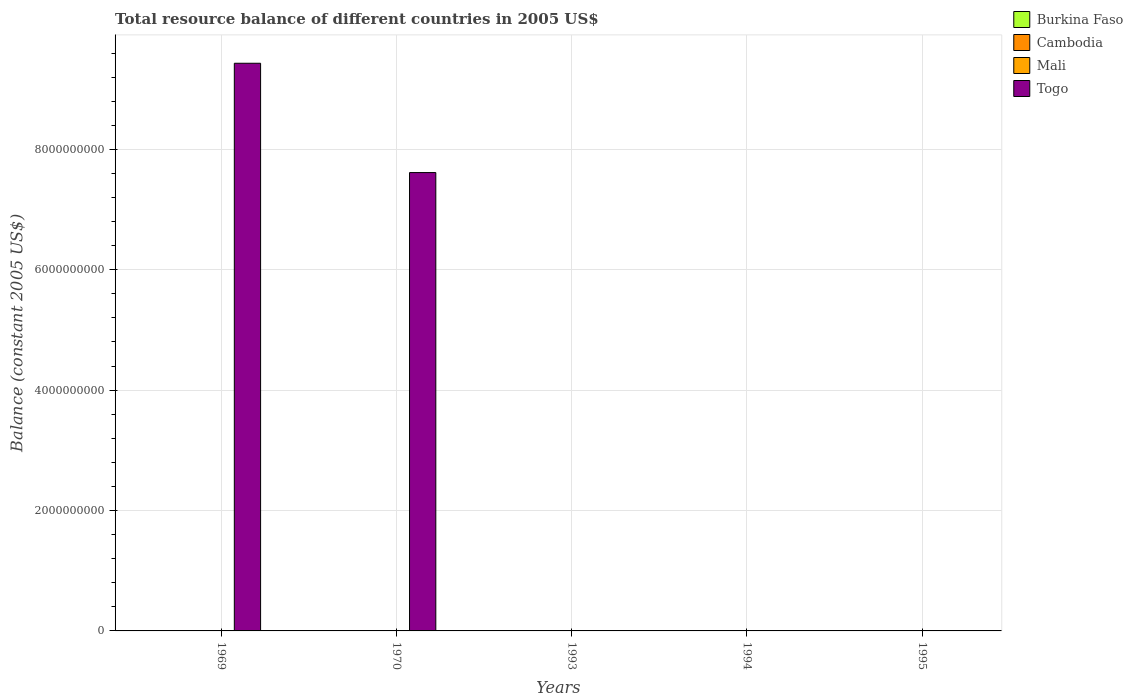How many different coloured bars are there?
Offer a very short reply. 1. Are the number of bars per tick equal to the number of legend labels?
Your answer should be compact. No. Are the number of bars on each tick of the X-axis equal?
Keep it short and to the point. No. How many bars are there on the 4th tick from the left?
Your answer should be compact. 0. How many bars are there on the 4th tick from the right?
Give a very brief answer. 1. What is the total resource balance in Togo in 1970?
Offer a very short reply. 7.61e+09. Across all years, what is the minimum total resource balance in Togo?
Provide a short and direct response. 0. In which year was the total resource balance in Togo maximum?
Your answer should be very brief. 1969. What is the difference between the total resource balance in Cambodia in 1994 and the total resource balance in Burkina Faso in 1995?
Your answer should be compact. 0. What is the difference between the highest and the lowest total resource balance in Togo?
Offer a very short reply. 9.43e+09. In how many years, is the total resource balance in Burkina Faso greater than the average total resource balance in Burkina Faso taken over all years?
Ensure brevity in your answer.  0. Is it the case that in every year, the sum of the total resource balance in Mali and total resource balance in Burkina Faso is greater than the sum of total resource balance in Togo and total resource balance in Cambodia?
Make the answer very short. No. Is it the case that in every year, the sum of the total resource balance in Burkina Faso and total resource balance in Mali is greater than the total resource balance in Cambodia?
Provide a short and direct response. No. Are all the bars in the graph horizontal?
Provide a short and direct response. No. Does the graph contain grids?
Offer a very short reply. Yes. Where does the legend appear in the graph?
Provide a succinct answer. Top right. How many legend labels are there?
Offer a very short reply. 4. How are the legend labels stacked?
Your response must be concise. Vertical. What is the title of the graph?
Your answer should be compact. Total resource balance of different countries in 2005 US$. What is the label or title of the Y-axis?
Provide a succinct answer. Balance (constant 2005 US$). What is the Balance (constant 2005 US$) in Cambodia in 1969?
Provide a succinct answer. 0. What is the Balance (constant 2005 US$) in Mali in 1969?
Ensure brevity in your answer.  0. What is the Balance (constant 2005 US$) of Togo in 1969?
Keep it short and to the point. 9.43e+09. What is the Balance (constant 2005 US$) in Mali in 1970?
Provide a short and direct response. 0. What is the Balance (constant 2005 US$) of Togo in 1970?
Offer a very short reply. 7.61e+09. What is the Balance (constant 2005 US$) in Cambodia in 1993?
Your answer should be compact. 0. What is the Balance (constant 2005 US$) of Burkina Faso in 1994?
Provide a succinct answer. 0. What is the Balance (constant 2005 US$) in Cambodia in 1995?
Your answer should be very brief. 0. What is the Balance (constant 2005 US$) in Mali in 1995?
Offer a terse response. 0. Across all years, what is the maximum Balance (constant 2005 US$) in Togo?
Keep it short and to the point. 9.43e+09. Across all years, what is the minimum Balance (constant 2005 US$) in Togo?
Provide a short and direct response. 0. What is the total Balance (constant 2005 US$) of Burkina Faso in the graph?
Offer a very short reply. 0. What is the total Balance (constant 2005 US$) of Togo in the graph?
Make the answer very short. 1.70e+1. What is the difference between the Balance (constant 2005 US$) in Togo in 1969 and that in 1970?
Give a very brief answer. 1.82e+09. What is the average Balance (constant 2005 US$) of Burkina Faso per year?
Offer a very short reply. 0. What is the average Balance (constant 2005 US$) in Togo per year?
Provide a short and direct response. 3.41e+09. What is the ratio of the Balance (constant 2005 US$) in Togo in 1969 to that in 1970?
Your answer should be very brief. 1.24. What is the difference between the highest and the lowest Balance (constant 2005 US$) of Togo?
Ensure brevity in your answer.  9.43e+09. 